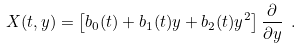<formula> <loc_0><loc_0><loc_500><loc_500>X ( t , y ) = \left [ b _ { 0 } ( t ) + b _ { 1 } ( t ) y + b _ { 2 } ( t ) y ^ { 2 } \right ] \frac { \partial } { \partial y } \ .</formula> 